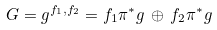<formula> <loc_0><loc_0><loc_500><loc_500>G = g ^ { f _ { 1 } , f _ { 2 } } = f _ { 1 } \pi ^ { * } g \, \oplus \, f _ { 2 } \pi ^ { * } g</formula> 